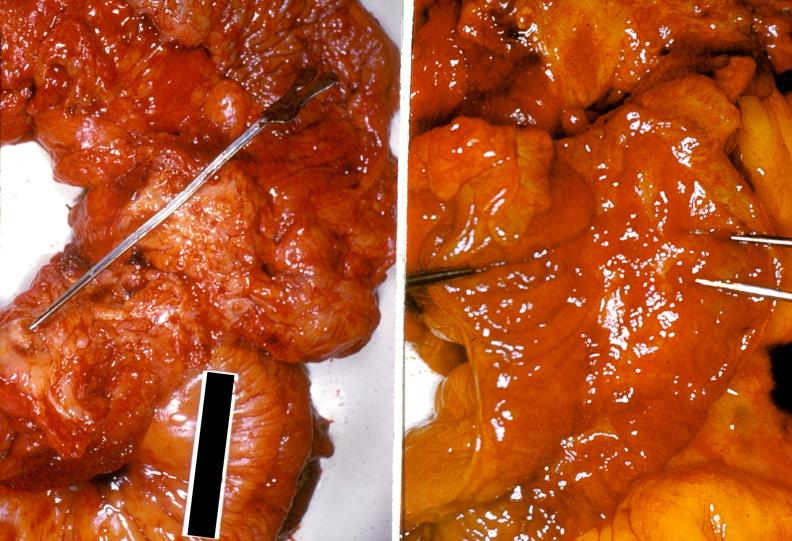does this image show ileum, ileitis due to chronic ulcerative colitis?
Answer the question using a single word or phrase. Yes 